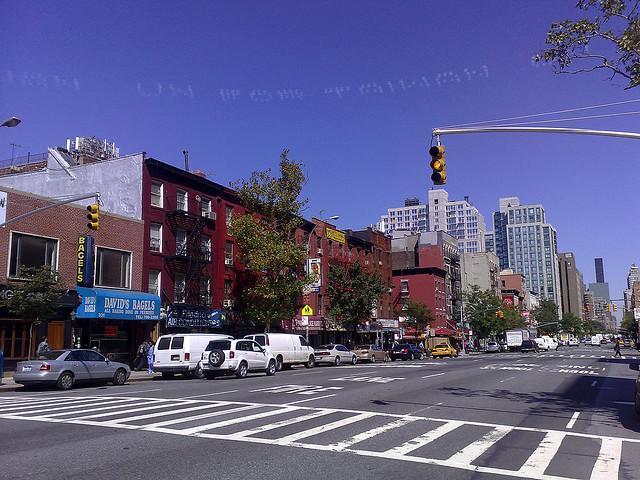How many cars can be seen?
Give a very brief answer. 2. 